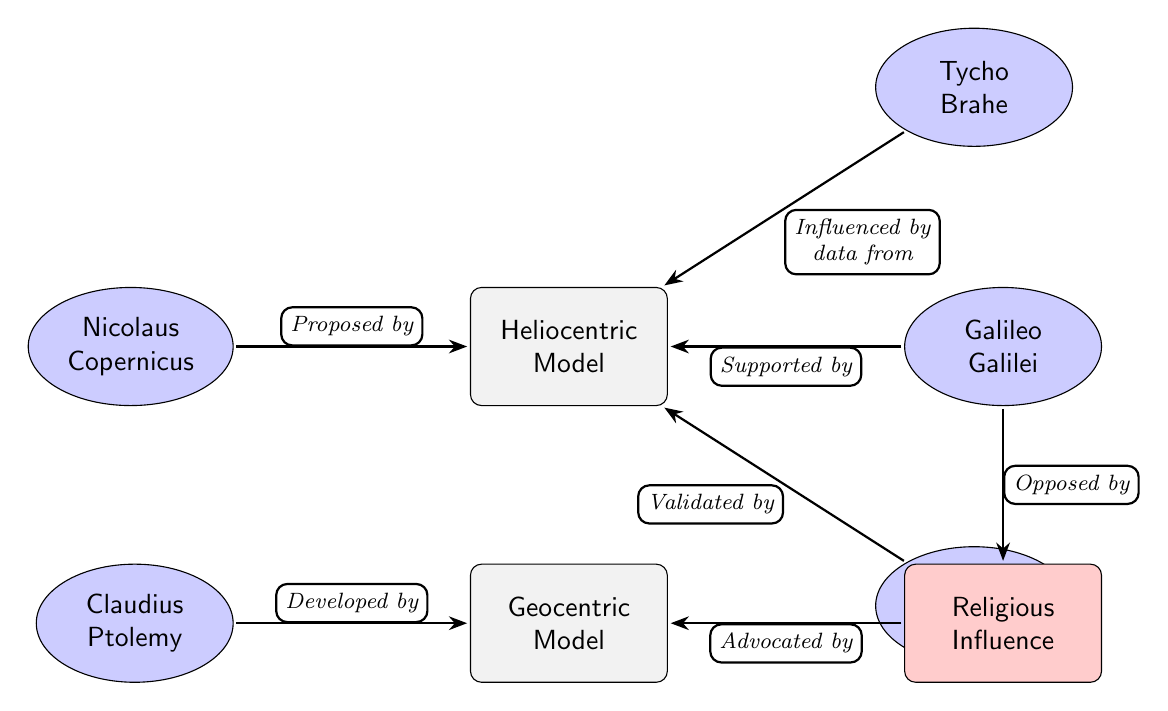What is the model proposed by Nicolaus Copernicus? The diagram shows a connection from Nicolaus Copernicus to the Heliocentric Model with the label "Proposed by." Therefore, the model he proposed is the Heliocentric Model.
Answer: Heliocentric Model How many people are connected to the Heliocentric Model? In the diagram, there are three people connected to the Heliocentric Model: Nicolaus Copernicus, Galileo Galilei, and Tycho Brahe. Thus, the count is three.
Answer: 3 Which model is developed by Claudius Ptolemy? The diagram shows a direct connection from Claudius Ptolemy to the Geocentric Model with the label "Developed by." This indicates that the model developed by him is the Geocentric Model.
Answer: Geocentric Model Who supported the Heliocentric Model? The diagram shows that Galileo Galilei is connected to the Heliocentric Model with the label "Supported by," indicating that he was a supporter of the Heliocentric Model.
Answer: Galileo Galilei What influence did religion have on the Geocentric Model? The diagram illustrates that there is an arrow pointing from "Religion" to the Geocentric Model labeled "Advocated by," which indicates that the Geocentric Model was advocated due to religious influence.
Answer: Advocated by Which individual is shown to have validated the Heliocentric Model? The diagram indicates that Isaac Newton is connected to the Heliocentric Model with the label "Validated by." This shows that he played a role in validating the Heliocentric Model.
Answer: Isaac Newton Who opposed the religious influence connected to the Geocentric Model? In the diagram, it shows an arrow from Galileo Galilei to "Religion" with the label "Opposed by," indicating that he opposed the religious influence that advocated the Geocentric Model.
Answer: Galileo Galilei Which model lacks direct external support in this diagram? The Geocentric Model does not show any support from individuals in this diagram, while the Heliocentric Model has several supporters. Therefore, the Geocentric Model lacks direct external support.
Answer: Geocentric Model What role did Tycho Brahe's data play in the context of the Heliocentric Model? The diagram connects Tycho Brahe to the Heliocentric Model with the label "Influenced by data from." This indicates that Tycho Brahe's data played an influential role in the development or support of the Heliocentric Model.
Answer: Influenced by data from 